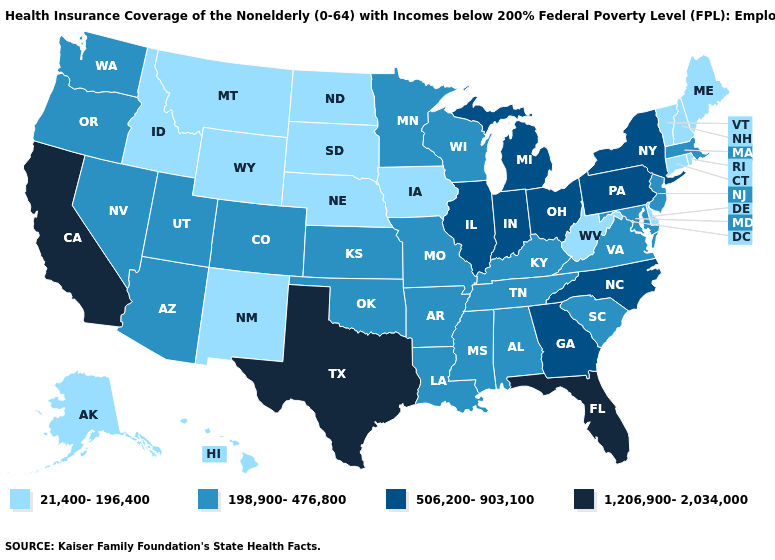Name the states that have a value in the range 198,900-476,800?
Short answer required. Alabama, Arizona, Arkansas, Colorado, Kansas, Kentucky, Louisiana, Maryland, Massachusetts, Minnesota, Mississippi, Missouri, Nevada, New Jersey, Oklahoma, Oregon, South Carolina, Tennessee, Utah, Virginia, Washington, Wisconsin. Name the states that have a value in the range 1,206,900-2,034,000?
Be succinct. California, Florida, Texas. Does Nebraska have a higher value than Colorado?
Keep it brief. No. Name the states that have a value in the range 1,206,900-2,034,000?
Short answer required. California, Florida, Texas. Does the first symbol in the legend represent the smallest category?
Keep it brief. Yes. Name the states that have a value in the range 1,206,900-2,034,000?
Be succinct. California, Florida, Texas. What is the value of Maryland?
Short answer required. 198,900-476,800. Among the states that border Colorado , does Nebraska have the lowest value?
Give a very brief answer. Yes. What is the highest value in the Northeast ?
Be succinct. 506,200-903,100. Does the map have missing data?
Be succinct. No. What is the value of Connecticut?
Write a very short answer. 21,400-196,400. Name the states that have a value in the range 21,400-196,400?
Quick response, please. Alaska, Connecticut, Delaware, Hawaii, Idaho, Iowa, Maine, Montana, Nebraska, New Hampshire, New Mexico, North Dakota, Rhode Island, South Dakota, Vermont, West Virginia, Wyoming. What is the value of Kentucky?
Quick response, please. 198,900-476,800. What is the highest value in states that border Iowa?
Concise answer only. 506,200-903,100. 